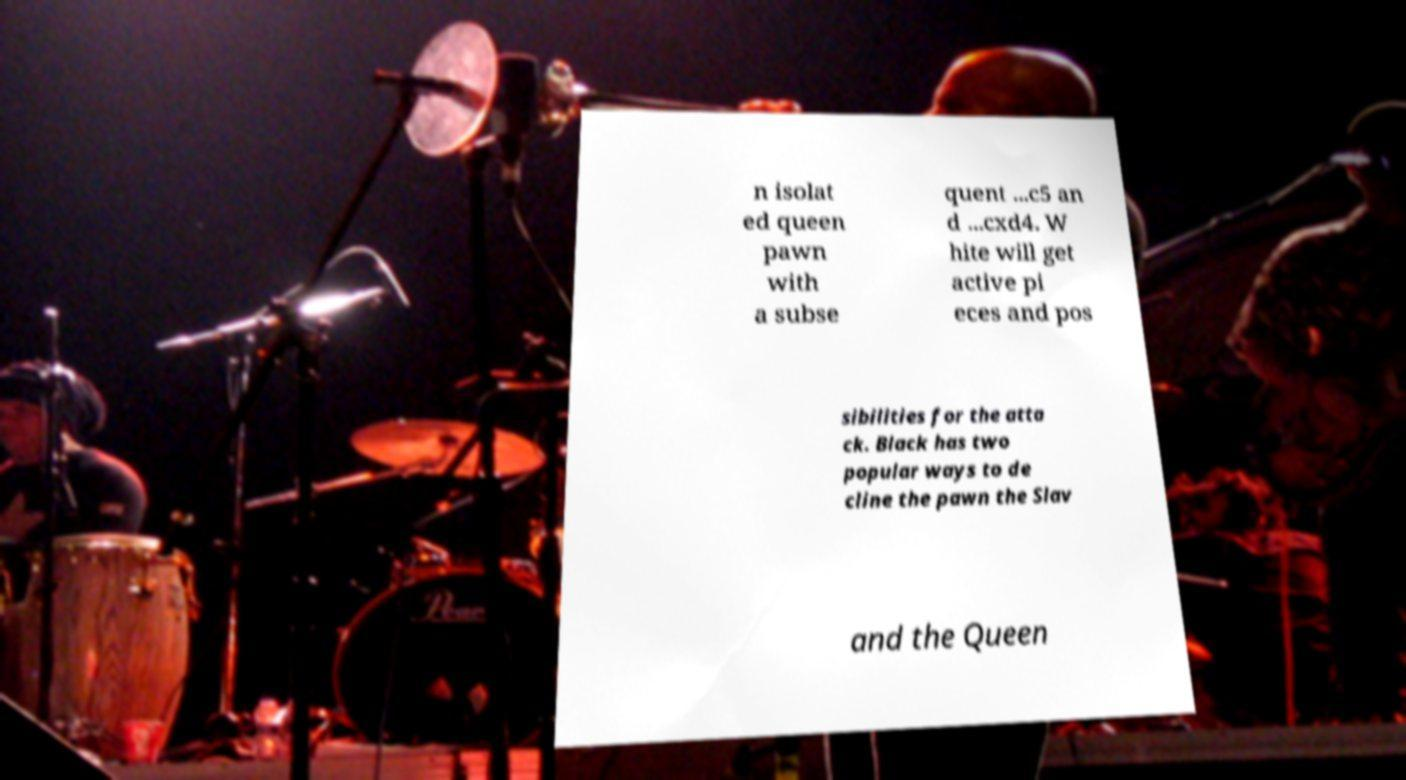Please identify and transcribe the text found in this image. n isolat ed queen pawn with a subse quent ...c5 an d ...cxd4. W hite will get active pi eces and pos sibilities for the atta ck. Black has two popular ways to de cline the pawn the Slav and the Queen 